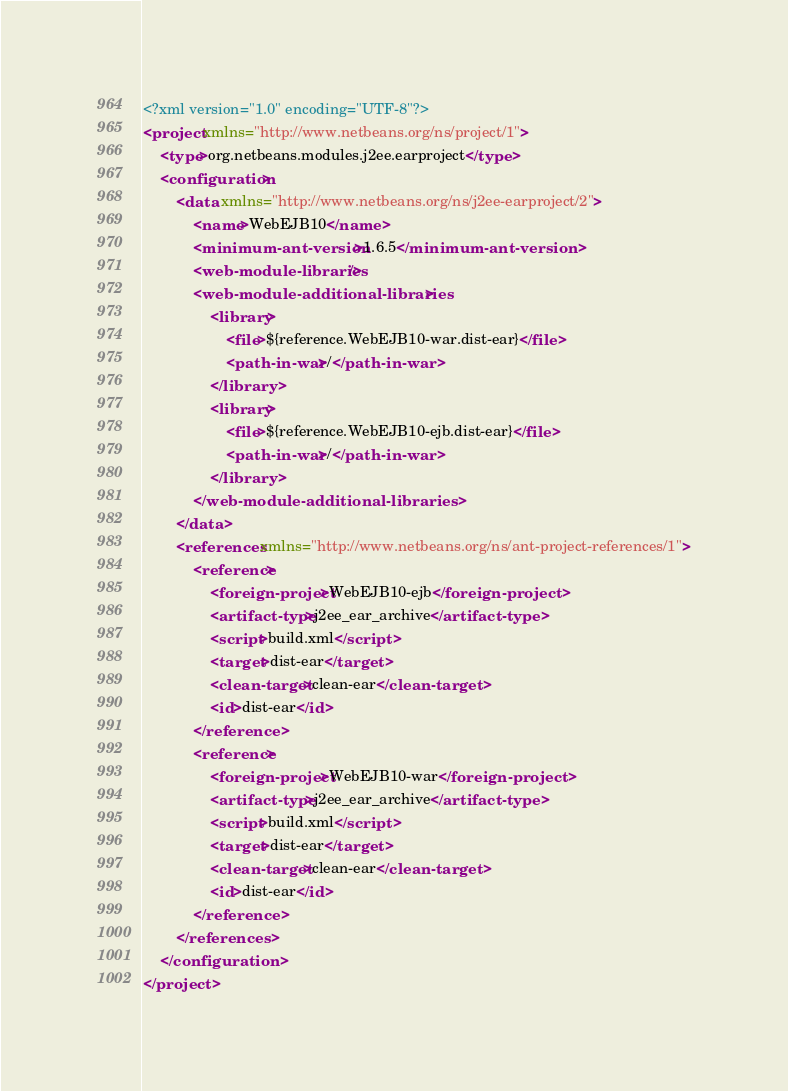<code> <loc_0><loc_0><loc_500><loc_500><_XML_><?xml version="1.0" encoding="UTF-8"?>
<project xmlns="http://www.netbeans.org/ns/project/1">
    <type>org.netbeans.modules.j2ee.earproject</type>
    <configuration>
        <data xmlns="http://www.netbeans.org/ns/j2ee-earproject/2">
            <name>WebEJB10</name>
            <minimum-ant-version>1.6.5</minimum-ant-version>
            <web-module-libraries/>
            <web-module-additional-libraries>
                <library>
                    <file>${reference.WebEJB10-war.dist-ear}</file>
                    <path-in-war>/</path-in-war>
                </library>
                <library>
                    <file>${reference.WebEJB10-ejb.dist-ear}</file>
                    <path-in-war>/</path-in-war>
                </library>
            </web-module-additional-libraries>
        </data>
        <references xmlns="http://www.netbeans.org/ns/ant-project-references/1">
            <reference>
                <foreign-project>WebEJB10-ejb</foreign-project>
                <artifact-type>j2ee_ear_archive</artifact-type>
                <script>build.xml</script>
                <target>dist-ear</target>
                <clean-target>clean-ear</clean-target>
                <id>dist-ear</id>
            </reference>
            <reference>
                <foreign-project>WebEJB10-war</foreign-project>
                <artifact-type>j2ee_ear_archive</artifact-type>
                <script>build.xml</script>
                <target>dist-ear</target>
                <clean-target>clean-ear</clean-target>
                <id>dist-ear</id>
            </reference>
        </references>
    </configuration>
</project>
</code> 